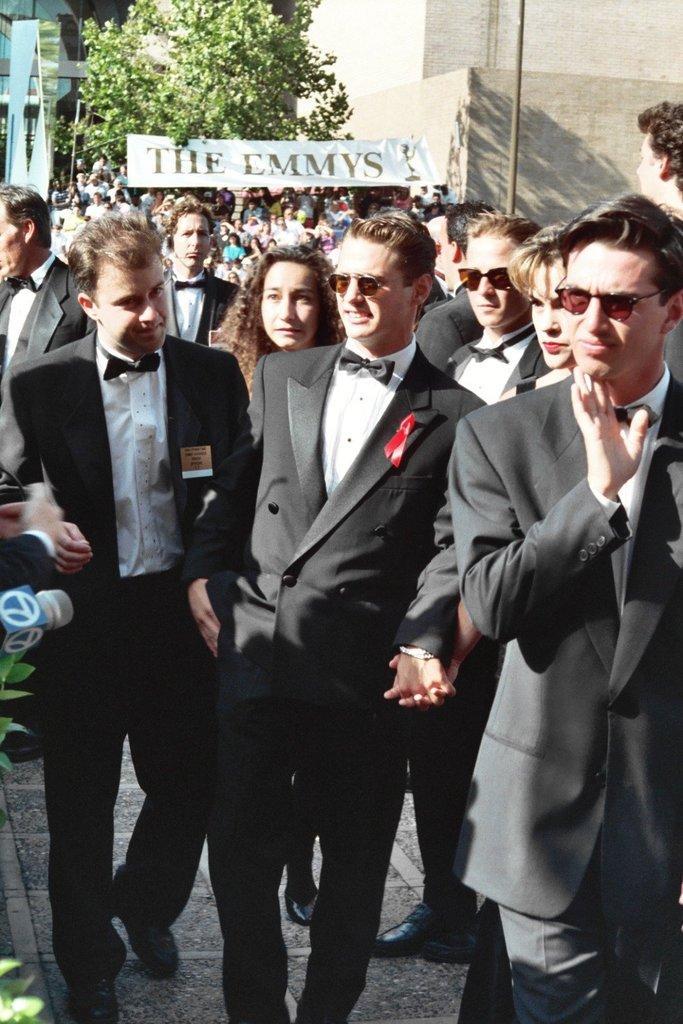Describe this image in one or two sentences. In this image I can see many people are walking on the ground. In the foreground, I can see few men are wearing black color suits and looking at the left side. In the background there is a tree and a building and also there is a white color banner on which I can see some text. On the right side there is a pole. 